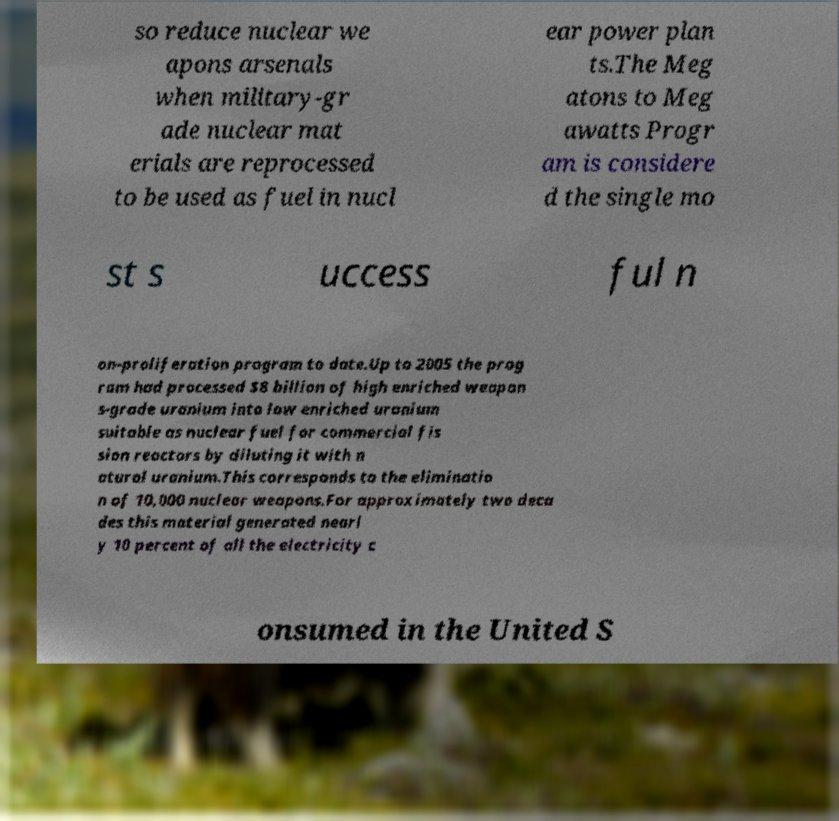Could you extract and type out the text from this image? so reduce nuclear we apons arsenals when military-gr ade nuclear mat erials are reprocessed to be used as fuel in nucl ear power plan ts.The Meg atons to Meg awatts Progr am is considere d the single mo st s uccess ful n on-proliferation program to date.Up to 2005 the prog ram had processed $8 billion of high enriched weapon s-grade uranium into low enriched uranium suitable as nuclear fuel for commercial fis sion reactors by diluting it with n atural uranium.This corresponds to the eliminatio n of 10,000 nuclear weapons.For approximately two deca des this material generated nearl y 10 percent of all the electricity c onsumed in the United S 